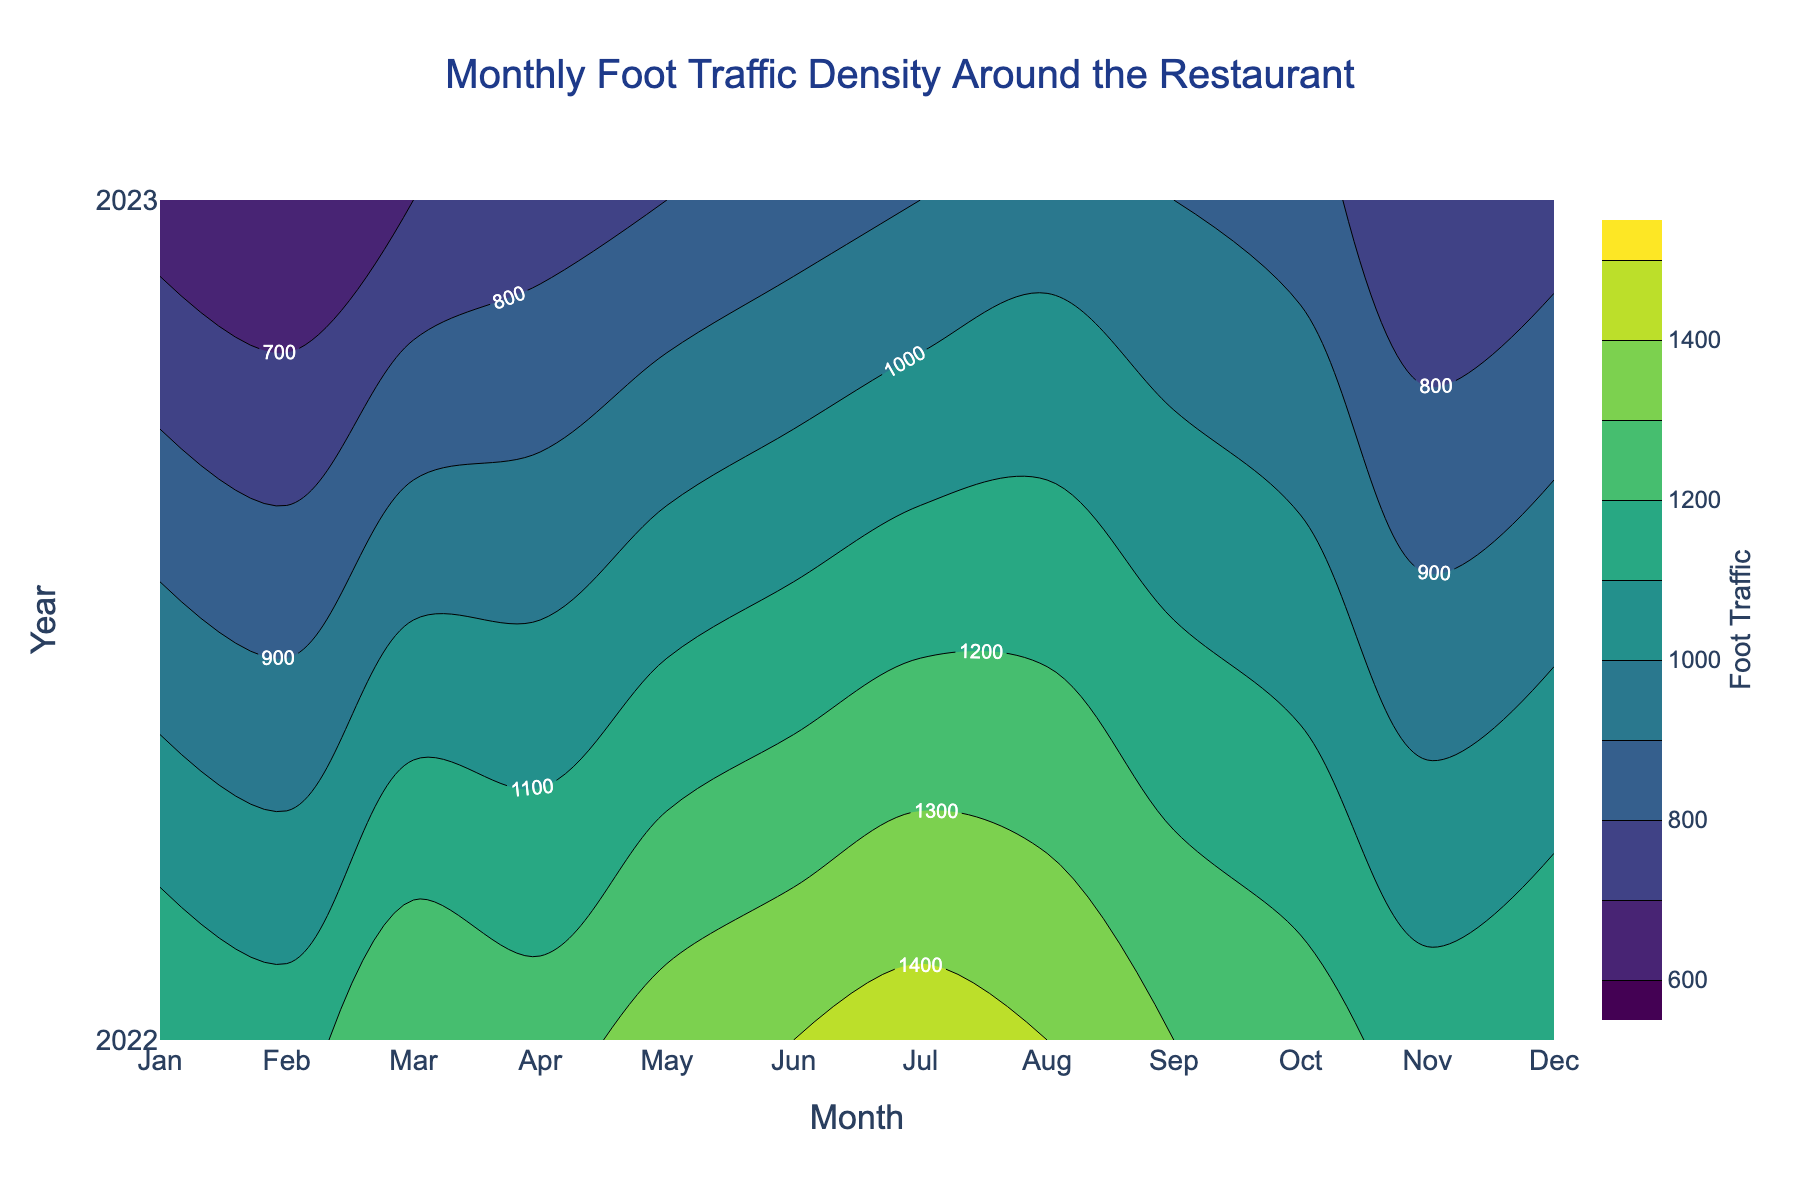What is the title of the plot? The title of the plot is found at the top center of the figure. It provides a summary of what the plot represents.
Answer: Monthly Foot Traffic Density Around the Restaurant What are the x and y axis titles? The x-axis title represents the months of the year, and the y-axis title represents the years. Looking at the axis, the x-axis title is 'Month' and the y-axis title is 'Year'.
Answer: Month; Year How does foot traffic change from January to December 2022? To determine the change, compare the foot traffic density from January 2022 to December 2022 on the contour plot. The figures show how the density changes over the months.
Answer: 1200 to 1200 Which month showed the lowest foot traffic in 2023? Identify the month with the smallest value on the contour plot for the year 2023. Observing the contour lines and the labels, the month with the lowest traffic can be found.
Answer: February Compare the foot traffic in January 2022 and January 2023. Which year had higher traffic? Check the foot traffic density for January 2022 and January 2023 on the contour plot. The contour labels show these specific values for comparison.
Answer: 2022 What is the general trend of foot traffic after the venue closure? Look at the contour plot for the year 2023 and observe the changes in foot traffic density over the months. The general trend can be deduced based on increasing or decreasing densities.
Answer: Increasing Which month in 2022 had the highest foot traffic? Examine the contour plot for the year 2022 and identify the month with the highest contour label value, indicating the highest foot traffic.
Answer: July How much did the foot traffic decrease from December 2022 to January 2023? To find the decrease, subtract the foot traffic value of January 2023 from December 2022. The values can be observed on the labels at the corresponding months.
Answer: 550 What is the range of foot traffic values displayed on the color scale? The color scale on the side of the contour plot shows the range of foot traffic values. This range can be identified by noting the minimum and maximum values displayed.
Answer: 600 to 1500 